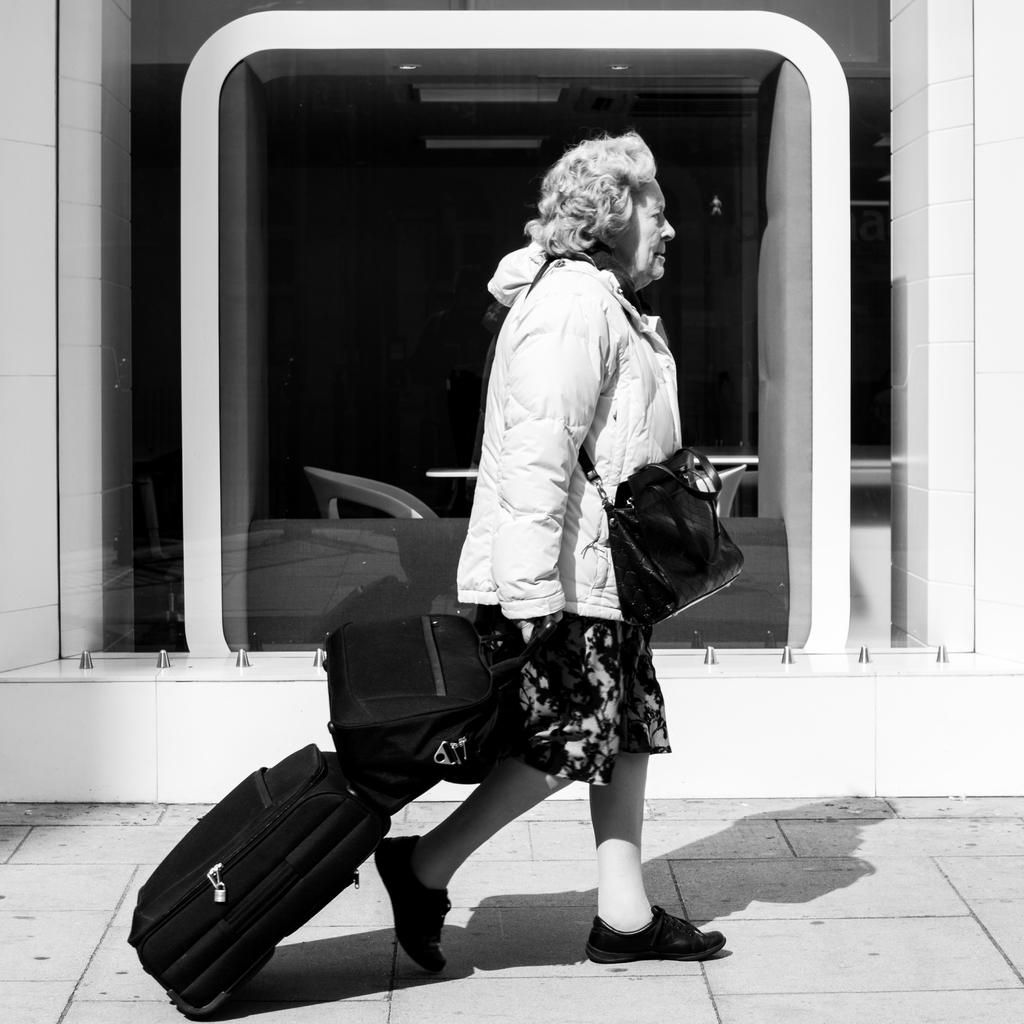What is the color scheme of the image? The image is black and white. Who is present in the image? There is a woman in the image. What is the woman doing in the image? The woman is walking. What items does the woman have with her? The woman has a trolley and a bag. What can be seen in the background of the image? There is a glass visible in the background of the image. How many children are playing with the yarn in the image? There is no yarn or children present in the image. 